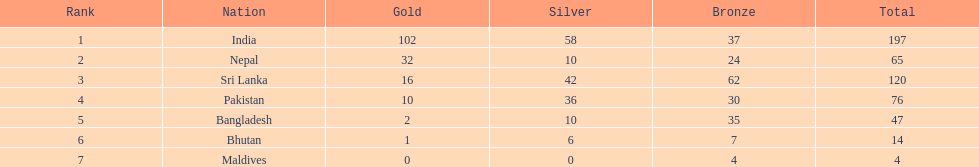Who has won the most bronze medals? Sri Lanka. Could you parse the entire table? {'header': ['Rank', 'Nation', 'Gold', 'Silver', 'Bronze', 'Total'], 'rows': [['1', 'India', '102', '58', '37', '197'], ['2', 'Nepal', '32', '10', '24', '65'], ['3', 'Sri Lanka', '16', '42', '62', '120'], ['4', 'Pakistan', '10', '36', '30', '76'], ['5', 'Bangladesh', '2', '10', '35', '47'], ['6', 'Bhutan', '1', '6', '7', '14'], ['7', 'Maldives', '0', '0', '4', '4']]} 